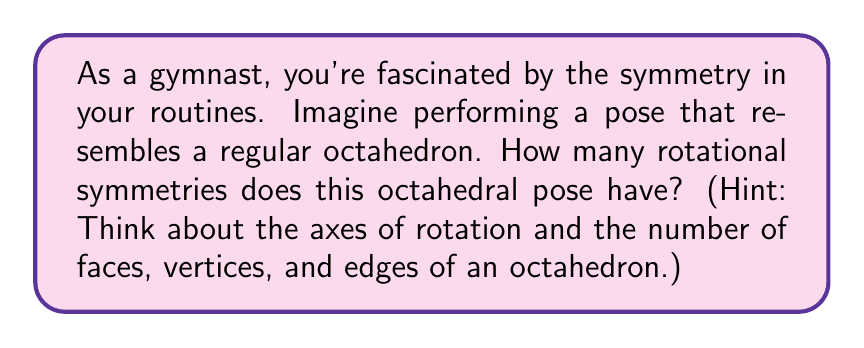Give your solution to this math problem. To determine the rotational symmetries of a regular octahedron, we need to consider its geometric properties:

1. Faces: An octahedron has 8 triangular faces.
2. Vertices: It has 6 vertices.
3. Edges: It has 12 edges.

Now, let's analyze the rotational symmetries:

1. Face-to-face rotations:
   - There are 4 axes passing through the centers of opposite faces.
   - Each axis has 3-fold rotational symmetry (120°, 240°, 360°).
   - Total symmetries: $4 \times 2 = 8$ (excluding identity rotation)

2. Vertex-to-vertex rotations:
   - There are 3 axes passing through opposite vertices.
   - Each axis has 2-fold rotational symmetry (180°, 360°).
   - Total symmetries: $3 \times 1 = 3$ (excluding identity rotation)

3. Edge-to-edge rotations:
   - There are 6 axes passing through the midpoints of opposite edges.
   - Each axis has 2-fold rotational symmetry (180°, 360°).
   - Total symmetries: $6 \times 1 = 6$ (excluding identity rotation)

4. Identity rotation:
   - The trivial rotation of 360° (or 0°) is also counted.
   - Total symmetries: 1

To calculate the total number of rotational symmetries, we sum up all the above:

$$\text{Total rotational symmetries} = 8 + 3 + 6 + 1 = 18$$

Therefore, a regular octahedron has 18 rotational symmetries.

[asy]
import three;

size(200);
currentprojection=perspective(6,3,2);

triple[] v={
  (1,1,1),(-1,-1,1),(-1,1,-1),(1,-1,-1),
  (1,-1,1),(-1,1,1),(-1,-1,-1),(1,1,-1)
};

for(int i=0; i<8; ++i)
  dot(v[i],red);

for(int i=0; i<4; ++i)
  for(int j=i+1; j<4; ++j)
    draw(v[i]--v[j],blue);

for(int i=4; i<8; ++i)
  for(int j=i+1; j<8; ++j)
    draw(v[i]--v[j],blue);

for(int i=0; i<4; ++i)
  for(int j=4; j<8; ++j)
    if(abs(dot(v[i],v[j]))<1e-5)
      draw(v[i]--v[j],blue);

label("Regular Octahedron", (0,-2,0), S);
[/asy]
Answer: 18 rotational symmetries 